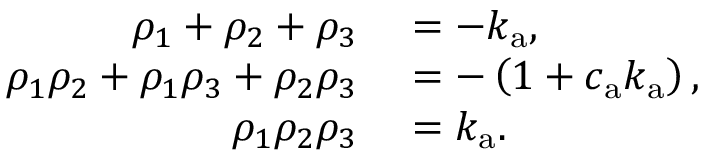Convert formula to latex. <formula><loc_0><loc_0><loc_500><loc_500>\begin{array} { r l } { \rho _ { 1 } + \rho _ { 2 } + \rho _ { 3 } } & = - k _ { a } , } \\ { \rho _ { 1 } \rho _ { 2 } + \rho _ { 1 } \rho _ { 3 } + \rho _ { 2 } \rho _ { 3 } } & = - \left ( 1 + c _ { a } k _ { a } \right ) , } \\ { \rho _ { 1 } \rho _ { 2 } \rho _ { 3 } } & = k _ { a } . } \end{array}</formula> 